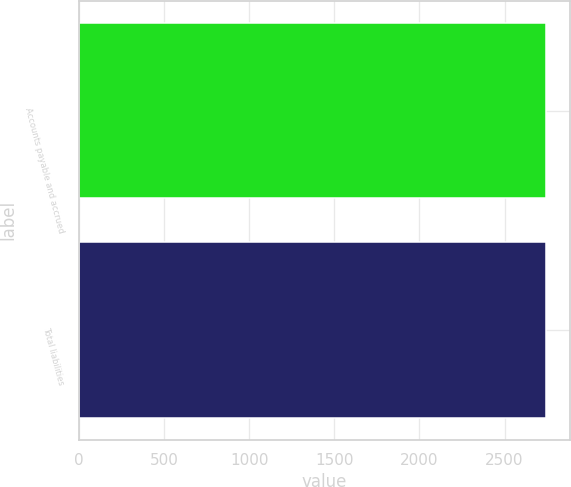Convert chart. <chart><loc_0><loc_0><loc_500><loc_500><bar_chart><fcel>Accounts payable and accrued<fcel>Total liabilities<nl><fcel>2744<fcel>2744.1<nl></chart> 